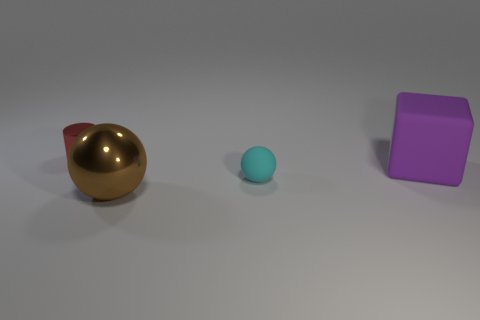There is a block that is the same material as the small cyan thing; what size is it?
Offer a very short reply. Large. How many brown metal objects are the same shape as the tiny cyan thing?
Offer a very short reply. 1. How many big blocks are there?
Your answer should be very brief. 1. There is a large thing that is in front of the tiny ball; is its shape the same as the tiny cyan matte thing?
Ensure brevity in your answer.  Yes. There is a thing that is the same size as the cyan matte sphere; what is it made of?
Provide a succinct answer. Metal. Is there a large brown object made of the same material as the small red object?
Your answer should be compact. Yes. Is the shape of the big metal thing the same as the small object that is to the right of the big brown shiny object?
Provide a short and direct response. Yes. What number of metallic things are behind the tiny cyan ball and to the right of the tiny red object?
Offer a terse response. 0. Are the small sphere and the large purple block that is behind the tiny ball made of the same material?
Keep it short and to the point. Yes. Is the number of tiny metallic cylinders behind the tiny cylinder the same as the number of cyan rubber spheres?
Offer a terse response. No. 